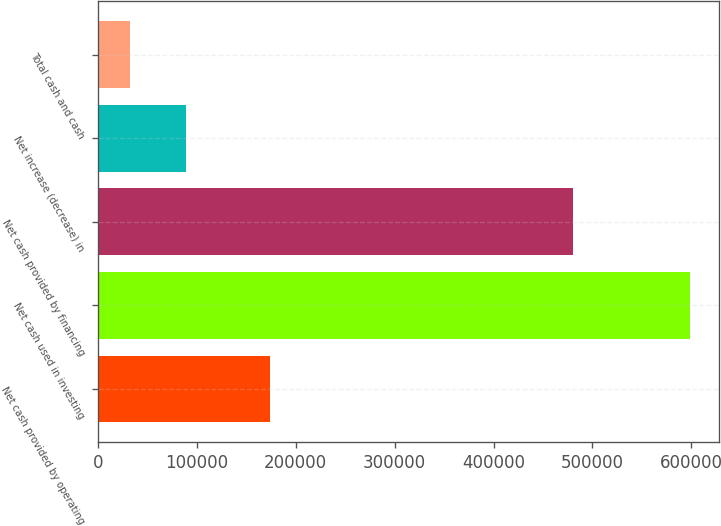Convert chart to OTSL. <chart><loc_0><loc_0><loc_500><loc_500><bar_chart><fcel>Net cash provided by operating<fcel>Net cash used in investing<fcel>Net cash provided by financing<fcel>Net increase (decrease) in<fcel>Total cash and cash<nl><fcel>173786<fcel>598309<fcel>480237<fcel>88733.5<fcel>32114<nl></chart> 